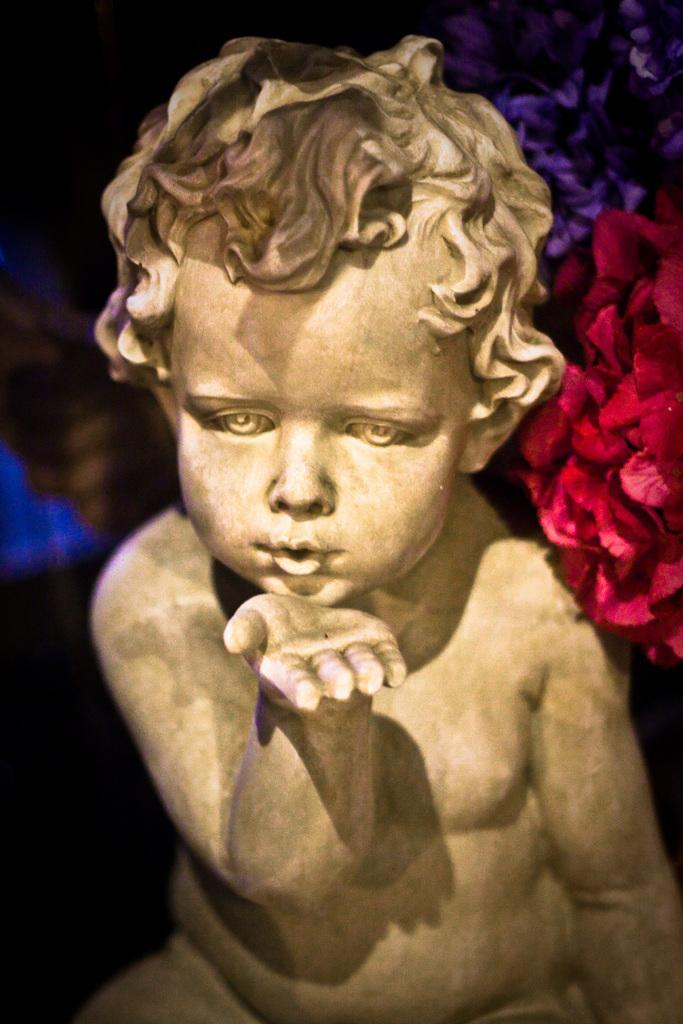What is the main subject in the image? There is a statue in the image. Can you describe any other elements in the image? Yes, there are colorful flowers in the top right hand corner of the image. What type of toothpaste is being used to clean the statue in the image? There is no toothpaste present in the image, and the statue is not being cleaned. 